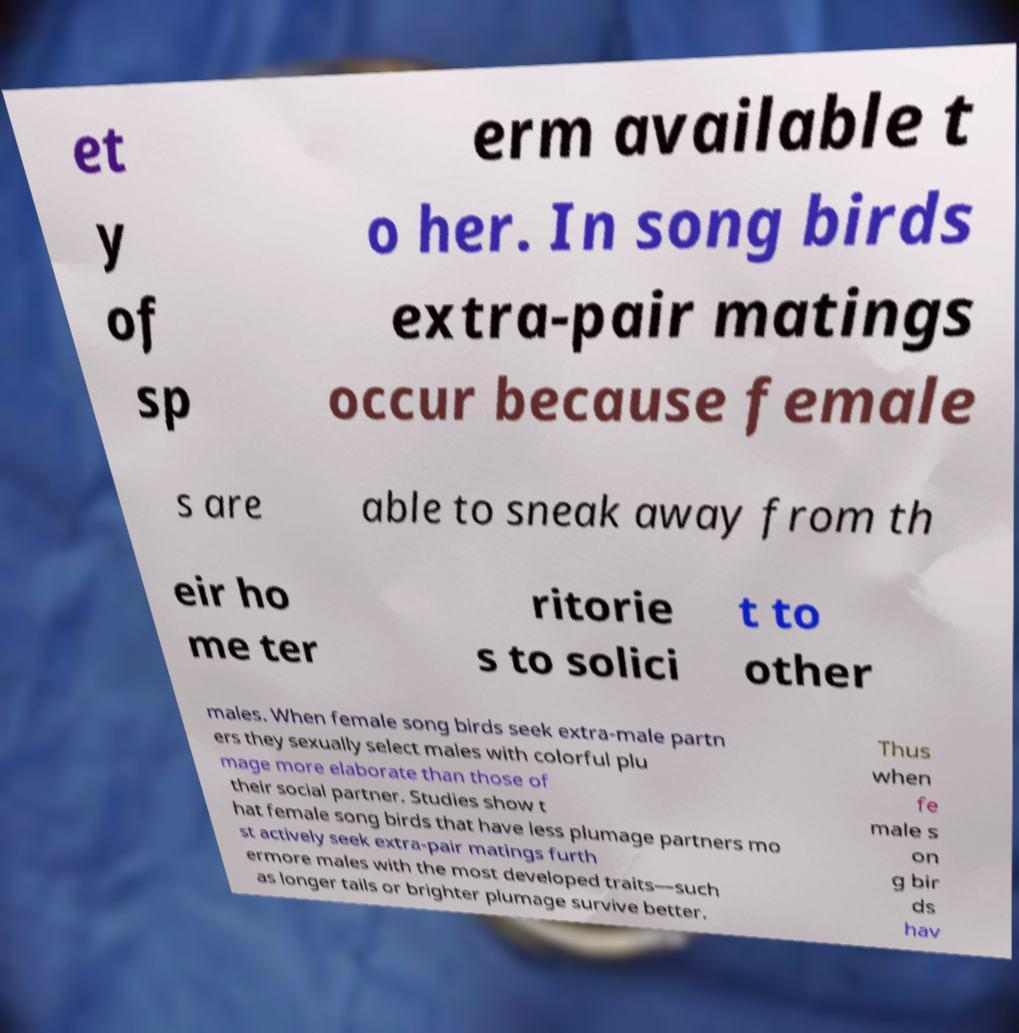I need the written content from this picture converted into text. Can you do that? et y of sp erm available t o her. In song birds extra-pair matings occur because female s are able to sneak away from th eir ho me ter ritorie s to solici t to other males. When female song birds seek extra-male partn ers they sexually select males with colorful plu mage more elaborate than those of their social partner. Studies show t hat female song birds that have less plumage partners mo st actively seek extra-pair matings furth ermore males with the most developed traits—such as longer tails or brighter plumage survive better. Thus when fe male s on g bir ds hav 